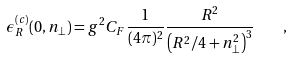Convert formula to latex. <formula><loc_0><loc_0><loc_500><loc_500>\epsilon _ { R } ^ { ( c ) } ( 0 , n _ { \perp } ) = g ^ { 2 } C _ { F } \frac { 1 } { ( 4 \pi ) ^ { 2 } } \frac { R ^ { 2 } } { \left ( R ^ { 2 } / 4 + n _ { \perp } ^ { 2 } \right ) ^ { 3 } } \quad ,</formula> 